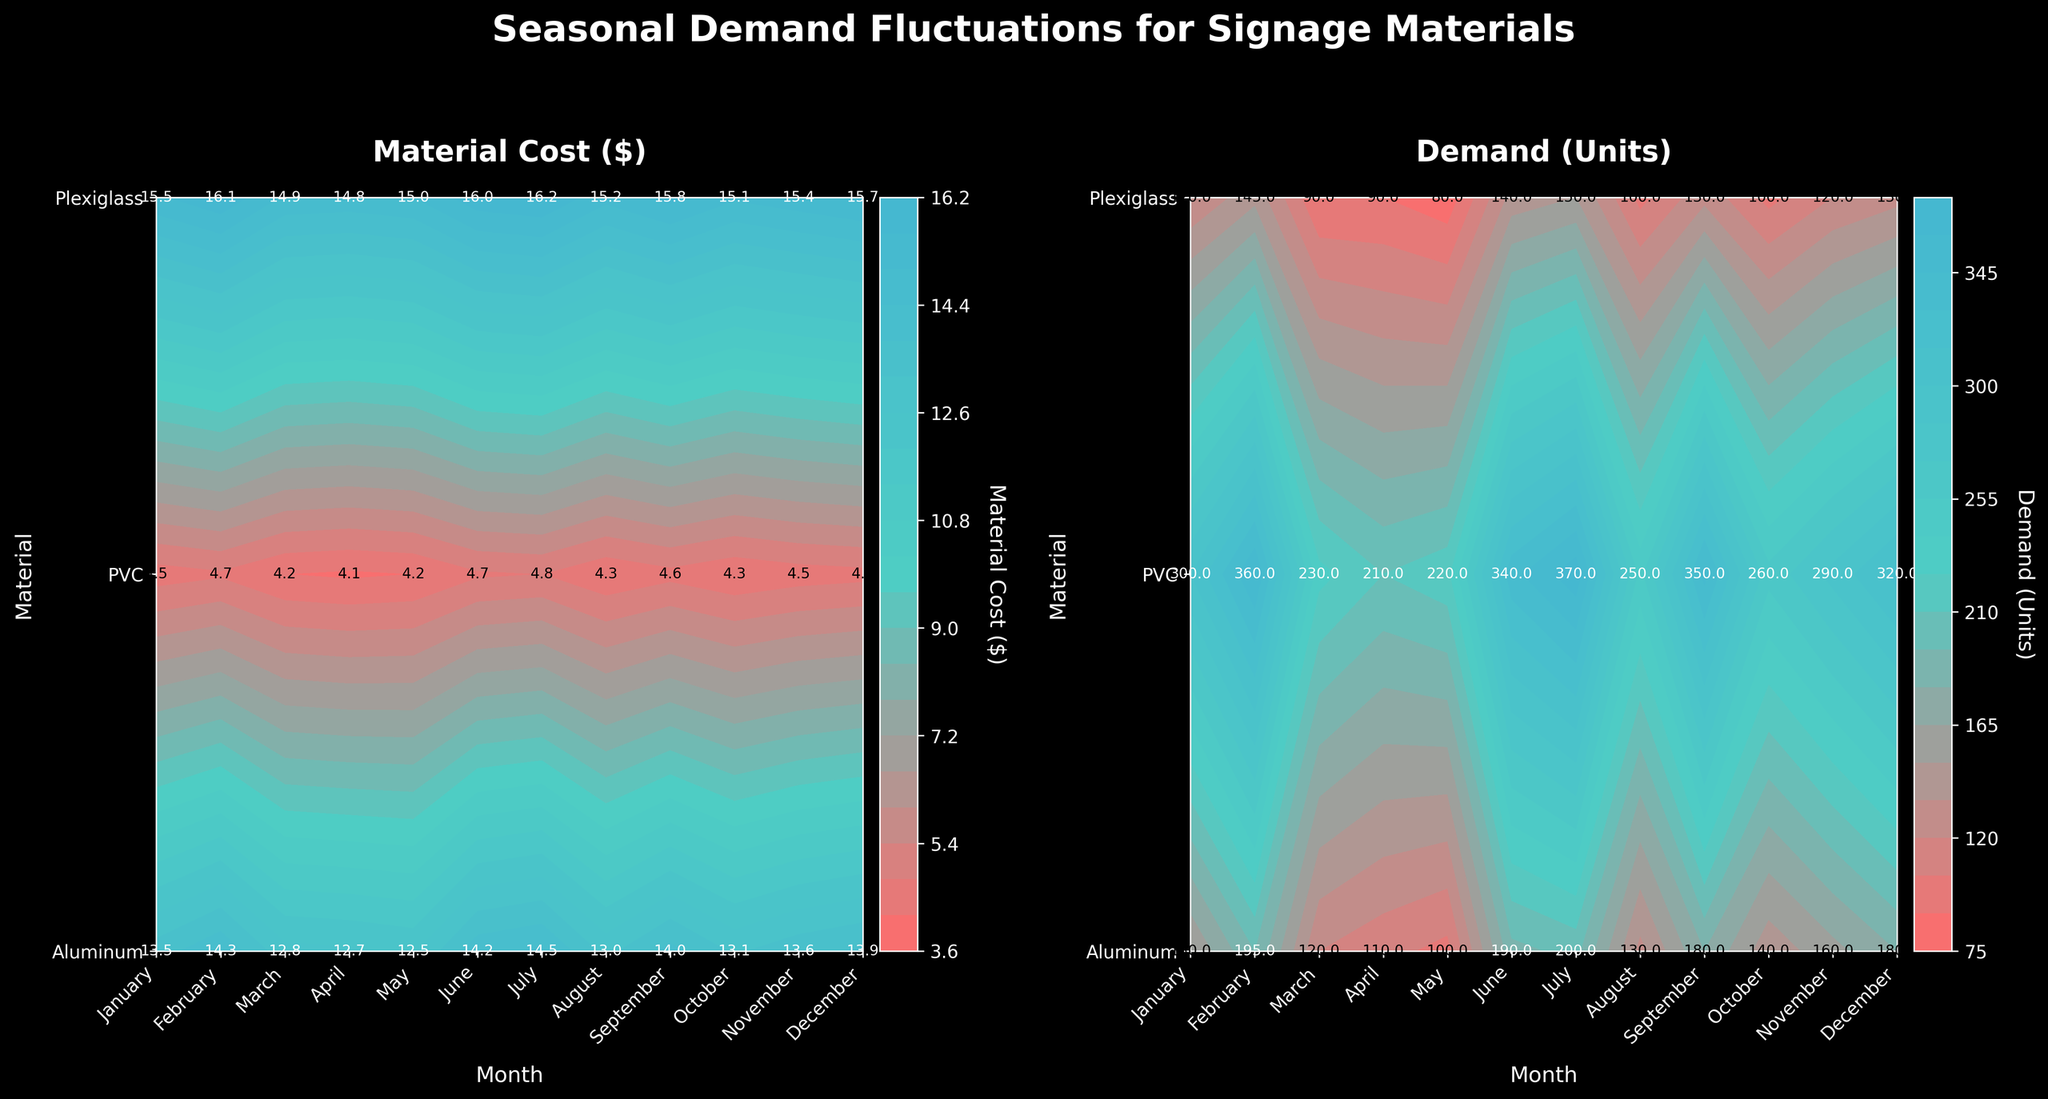What is the title of the figure? The title of the figure is located at the top center of the figure.
Answer: Seasonal Demand Fluctuations for Signage Materials What are the materials listed on the y-axis of both subplots? The materials are denoted by labels on the y-axis of the subplots.
Answer: Aluminum, PVC, Plexiglass How many months are displayed on the x-axis of the subplots? You can count the number of unique tick labels on the x-axis to determine the number of months.
Answer: 12 Which material has the highest demand in June? By looking at the demands subplot and finding the June data points, you can compare the values for each material and identify the highest one.
Answer: PVC How does the material cost of Plexiglass in December compare with that in January? Check the values in the material cost subplot for Plexiglass in December and January. Compare these two values to determine if there is an increase, decrease, or if they are the same.
Answer: Lower What is the average material cost for Aluminum from March to May? Sum up the material costs for Aluminum from March to May and divide by the number of months (3). The values are 13.0, 13.5, and 14.0 respectively: (13.0 + 13.5 + 14.0) / 3.
Answer: 13.5 What's the total demand for PVC from January to June? Add up the demand values for PVC for each month from January to June. The values are 220, 210, 250, 300, 350, and 370 respectively: 220 + 210 + 250 + 300 + 350 + 370.
Answer: 1700 What color represents the highest values on the contour plots? The color scheme of the contour plots indicates that higher values correspond to a certain color gradient. Identify this color from the plots.
Answer: Lighter color What is the range of material costs represented by the color bar in the material cost subplot? Look at the range of values displayed on the color bar legend next to the material cost subplot.
Answer: 4.2 to 16.2 